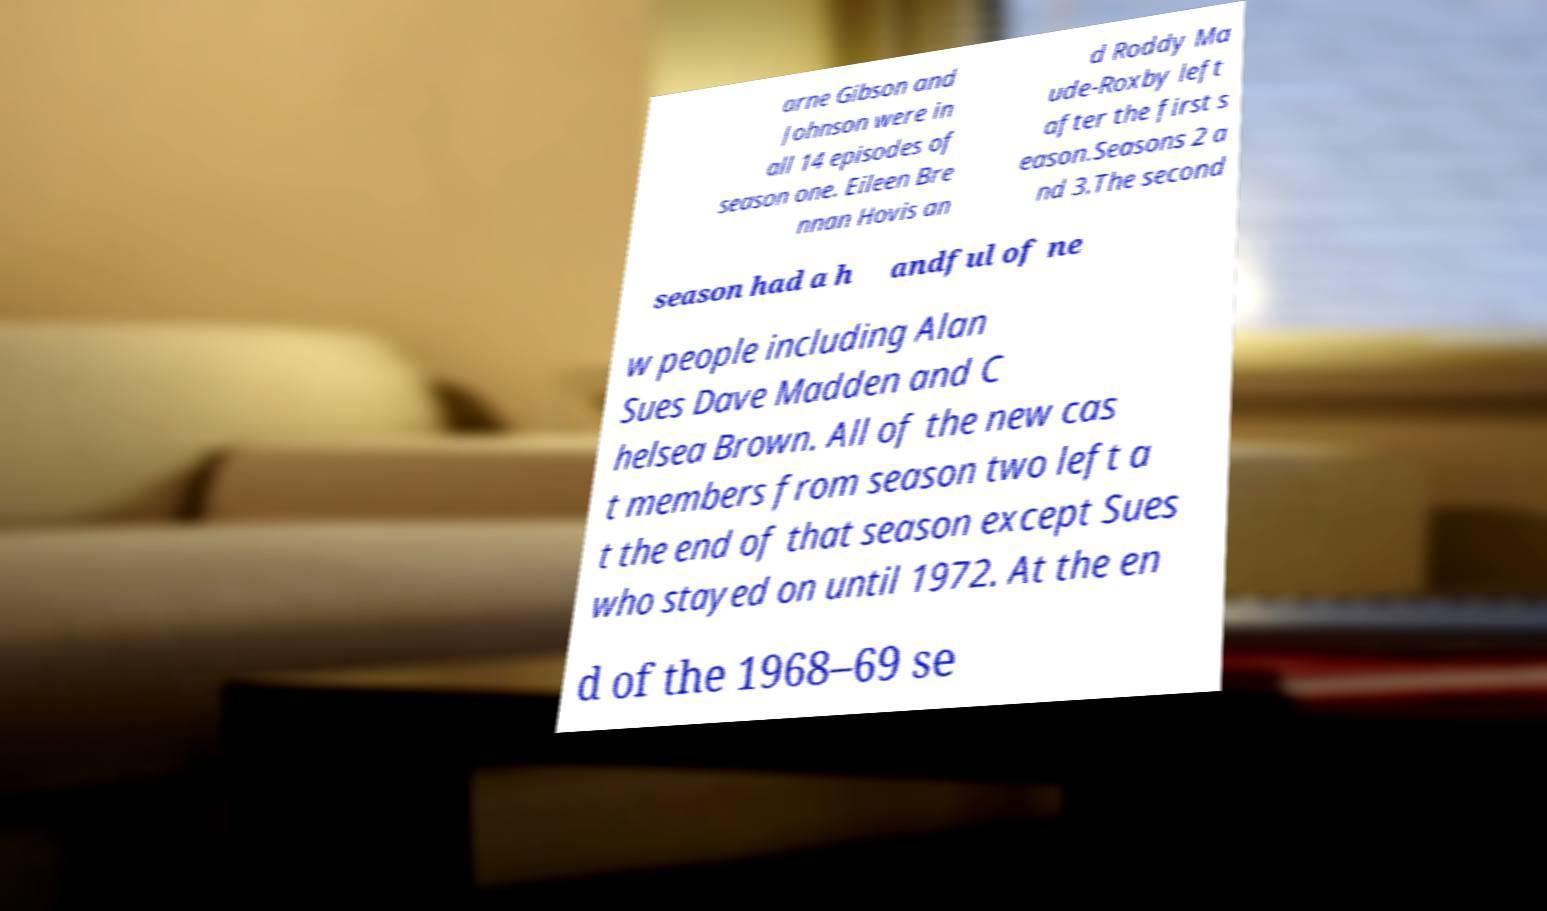Could you extract and type out the text from this image? arne Gibson and Johnson were in all 14 episodes of season one. Eileen Bre nnan Hovis an d Roddy Ma ude-Roxby left after the first s eason.Seasons 2 a nd 3.The second season had a h andful of ne w people including Alan Sues Dave Madden and C helsea Brown. All of the new cas t members from season two left a t the end of that season except Sues who stayed on until 1972. At the en d of the 1968–69 se 